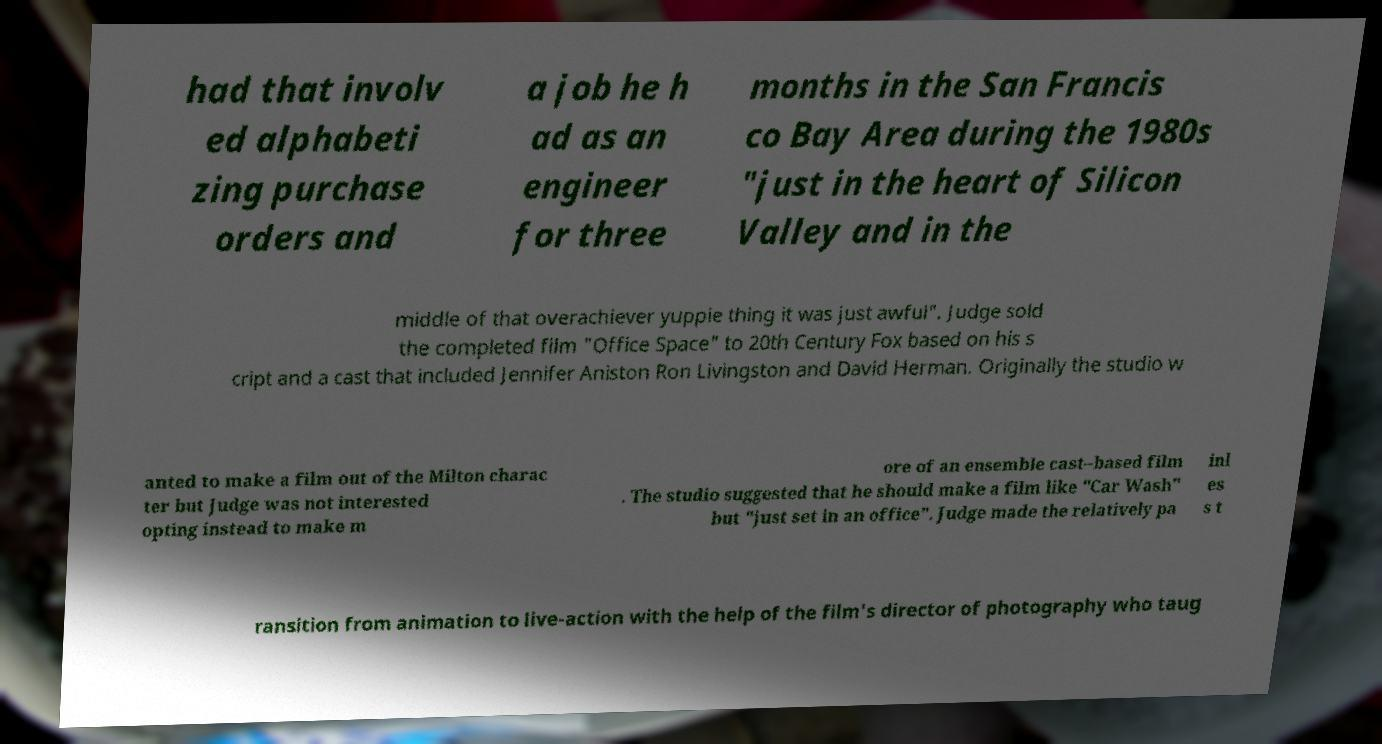Can you accurately transcribe the text from the provided image for me? had that involv ed alphabeti zing purchase orders and a job he h ad as an engineer for three months in the San Francis co Bay Area during the 1980s "just in the heart of Silicon Valley and in the middle of that overachiever yuppie thing it was just awful". Judge sold the completed film "Office Space" to 20th Century Fox based on his s cript and a cast that included Jennifer Aniston Ron Livingston and David Herman. Originally the studio w anted to make a film out of the Milton charac ter but Judge was not interested opting instead to make m ore of an ensemble cast–based film . The studio suggested that he should make a film like "Car Wash" but "just set in an office". Judge made the relatively pa inl es s t ransition from animation to live-action with the help of the film's director of photography who taug 